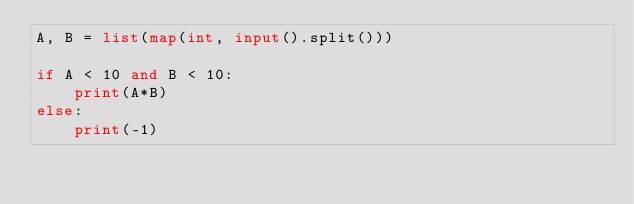<code> <loc_0><loc_0><loc_500><loc_500><_Python_>A, B = list(map(int, input().split()))

if A < 10 and B < 10:
    print(A*B)
else:
    print(-1)
</code> 